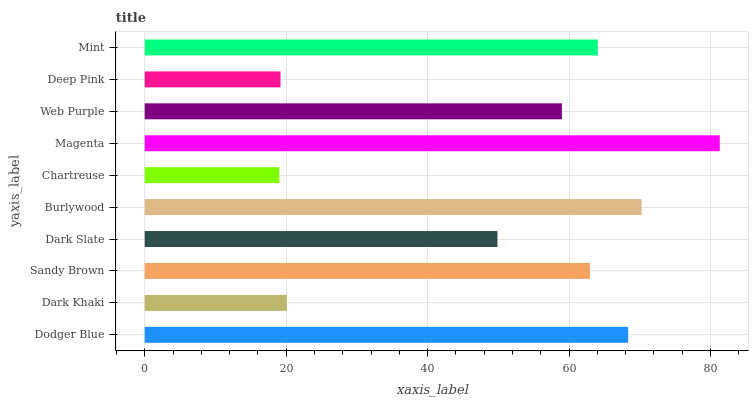Is Chartreuse the minimum?
Answer yes or no. Yes. Is Magenta the maximum?
Answer yes or no. Yes. Is Dark Khaki the minimum?
Answer yes or no. No. Is Dark Khaki the maximum?
Answer yes or no. No. Is Dodger Blue greater than Dark Khaki?
Answer yes or no. Yes. Is Dark Khaki less than Dodger Blue?
Answer yes or no. Yes. Is Dark Khaki greater than Dodger Blue?
Answer yes or no. No. Is Dodger Blue less than Dark Khaki?
Answer yes or no. No. Is Sandy Brown the high median?
Answer yes or no. Yes. Is Web Purple the low median?
Answer yes or no. Yes. Is Web Purple the high median?
Answer yes or no. No. Is Sandy Brown the low median?
Answer yes or no. No. 